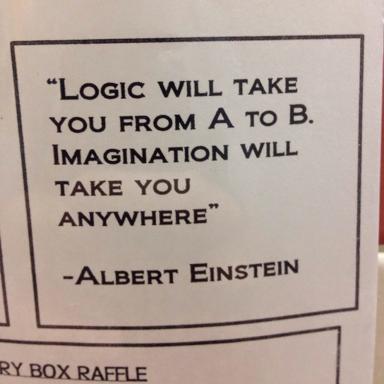What is the quote by Albert Einstein in the image? The quote by Albert Einstein depicted in the image reads, "Logic will take you from A to B. Imagination will take you anywhere." This encapsulates the belief that while logic is essential for systematic progress, imagination is limitless and can lead to novel discoveries and creative solutions. 